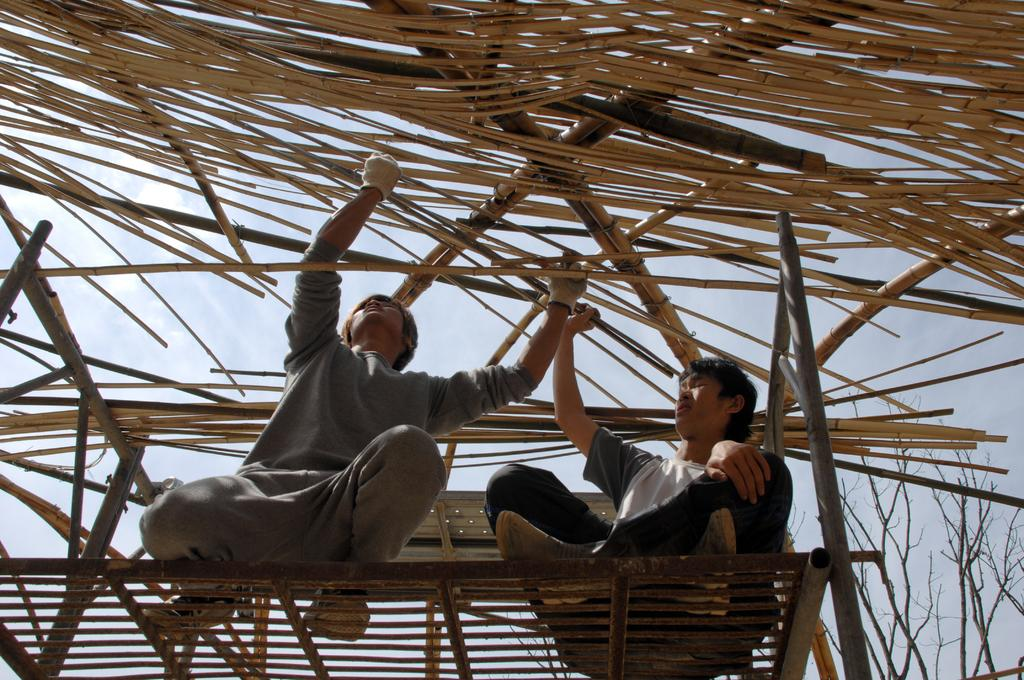How many people are on the platform in the image? There are two persons on the platform in the image. What are the persons doing on the platform? The persons are adjusting sticks above them. What can be seen in the background of the image? There are trees in the background of the image. What is visible in the sky in the image? There are clouds in the sky in the image. Can you see a deer in the image? No, there is no deer present in the image. Is the platform located near the sea in the image? No, there is no sea visible in the image; it only features trees in the background. 